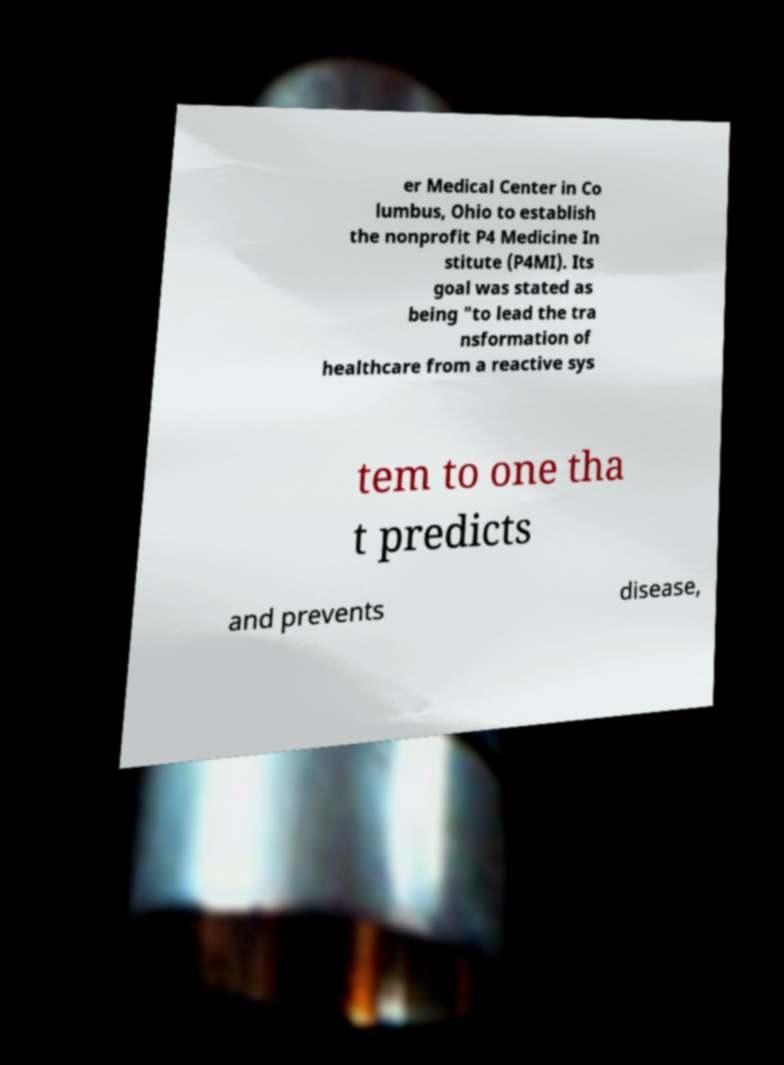Please read and relay the text visible in this image. What does it say? er Medical Center in Co lumbus, Ohio to establish the nonprofit P4 Medicine In stitute (P4MI). Its goal was stated as being "to lead the tra nsformation of healthcare from a reactive sys tem to one tha t predicts and prevents disease, 